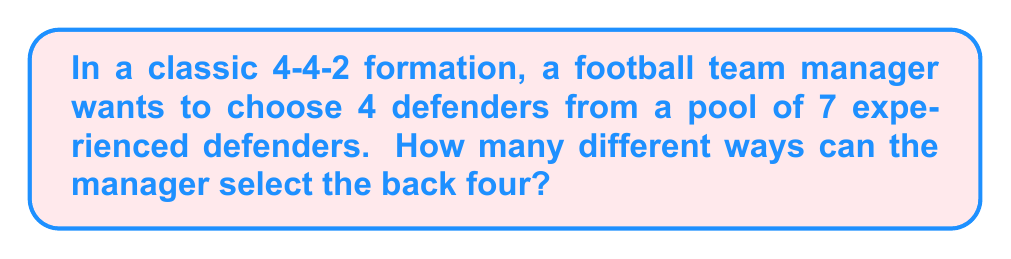Give your solution to this math problem. Let's approach this step-by-step:

1) This is a combination problem. We are selecting 4 defenders out of 7 available defenders, where the order doesn't matter (as long as we have the same 4 players, it's considered the same selection).

2) The formula for combinations is:

   $$C(n,r) = \frac{n!}{r!(n-r)!}$$

   Where $n$ is the total number of items to choose from, and $r$ is the number of items being chosen.

3) In this case, $n = 7$ (total defenders) and $r = 4$ (defenders we're selecting).

4) Let's substitute these values into our formula:

   $$C(7,4) = \frac{7!}{4!(7-4)!} = \frac{7!}{4!3!}$$

5) Expand this:
   $$\frac{7 \times 6 \times 5 \times 4!}{4! \times 3 \times 2 \times 1}$$

6) The 4! cancels out in the numerator and denominator:

   $$\frac{7 \times 6 \times 5}{3 \times 2 \times 1} = \frac{210}{6} = 35$$

Therefore, the manager can select the back four in 35 different ways.
Answer: 35 